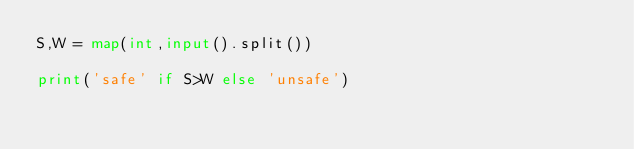Convert code to text. <code><loc_0><loc_0><loc_500><loc_500><_Python_>S,W = map(int,input().split())

print('safe' if S>W else 'unsafe')</code> 